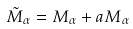Convert formula to latex. <formula><loc_0><loc_0><loc_500><loc_500>\tilde { M } _ { \alpha } = M _ { \alpha } + a M _ { \alpha }</formula> 